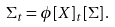<formula> <loc_0><loc_0><loc_500><loc_500>\Sigma _ { t } = \phi [ X ] _ { t } [ \Sigma ] \, .</formula> 